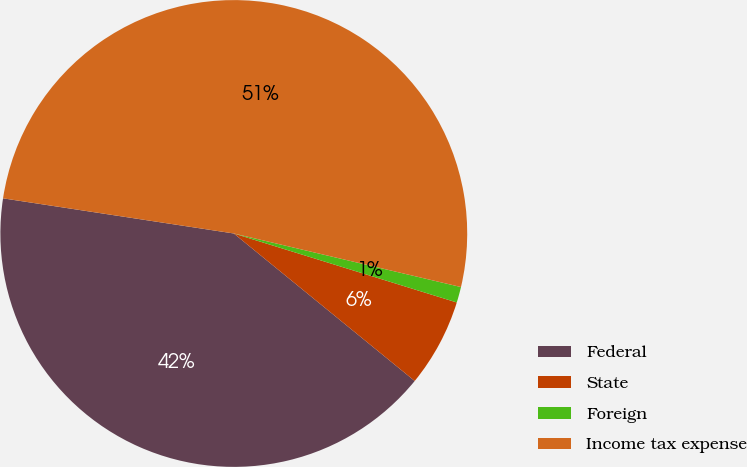Convert chart. <chart><loc_0><loc_0><loc_500><loc_500><pie_chart><fcel>Federal<fcel>State<fcel>Foreign<fcel>Income tax expense<nl><fcel>41.52%<fcel>6.11%<fcel>1.09%<fcel>51.28%<nl></chart> 